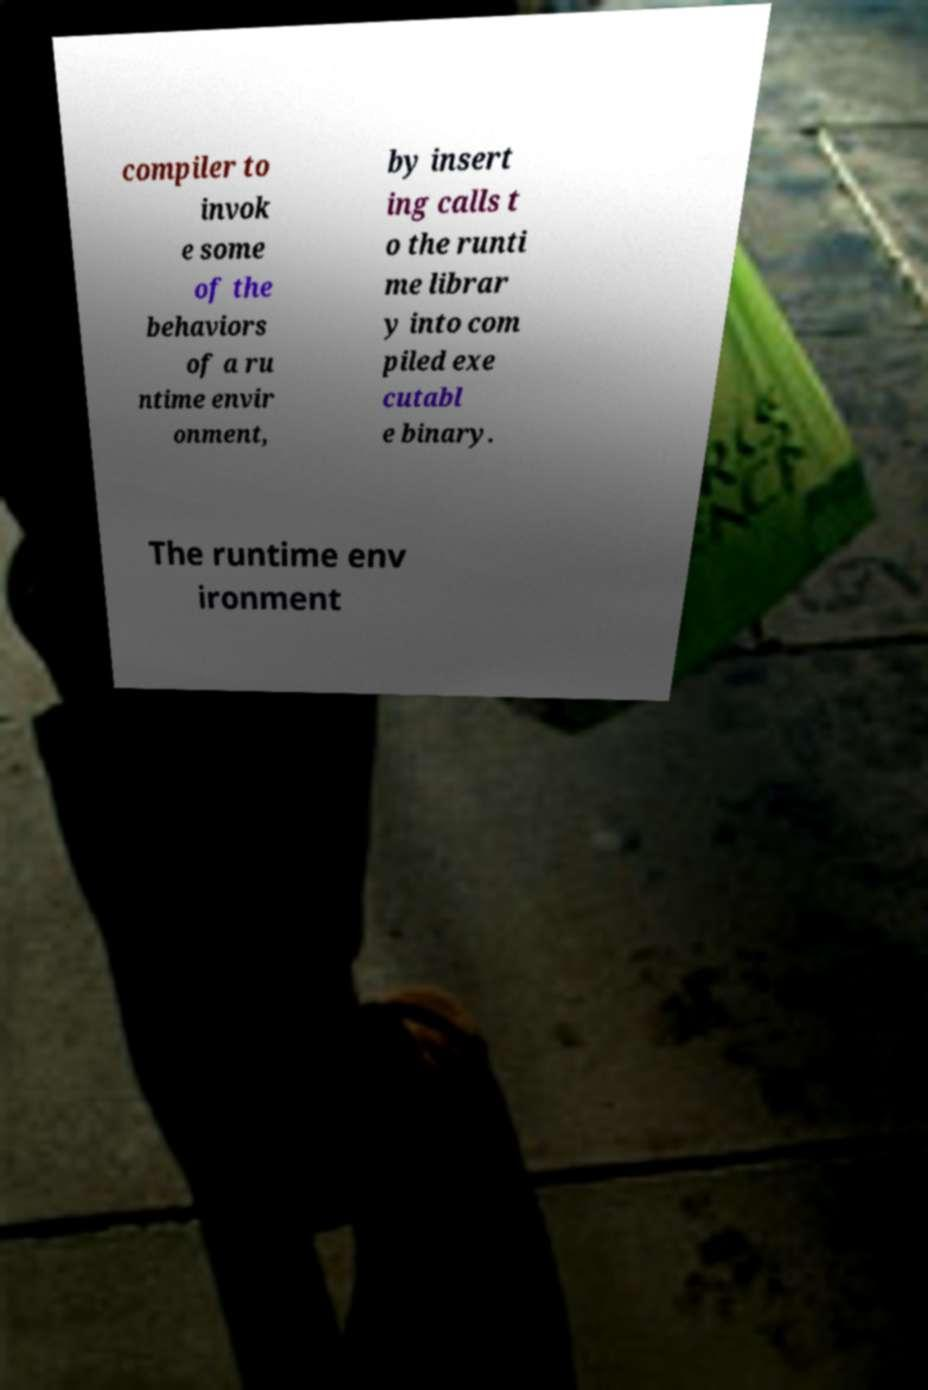Please read and relay the text visible in this image. What does it say? compiler to invok e some of the behaviors of a ru ntime envir onment, by insert ing calls t o the runti me librar y into com piled exe cutabl e binary. The runtime env ironment 